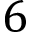<formula> <loc_0><loc_0><loc_500><loc_500>6</formula> 